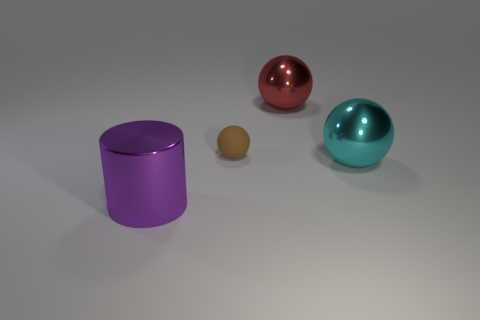What is the object that is right of the brown ball and behind the cyan ball made of?
Offer a very short reply. Metal. What number of big objects are in front of the thing that is behind the tiny object?
Your response must be concise. 2. What is the shape of the brown object?
Give a very brief answer. Sphere. There is a purple object that is made of the same material as the large cyan thing; what shape is it?
Provide a succinct answer. Cylinder. Do the large shiny thing behind the tiny matte sphere and the big cyan object have the same shape?
Provide a succinct answer. Yes. There is a thing behind the small object; what shape is it?
Your answer should be compact. Sphere. How many balls have the same size as the purple thing?
Keep it short and to the point. 2. What is the color of the tiny matte sphere?
Your answer should be compact. Brown. Is the color of the metallic cylinder the same as the small matte thing in front of the big red sphere?
Give a very brief answer. No. There is a cyan sphere that is the same material as the purple thing; what size is it?
Offer a terse response. Large. 